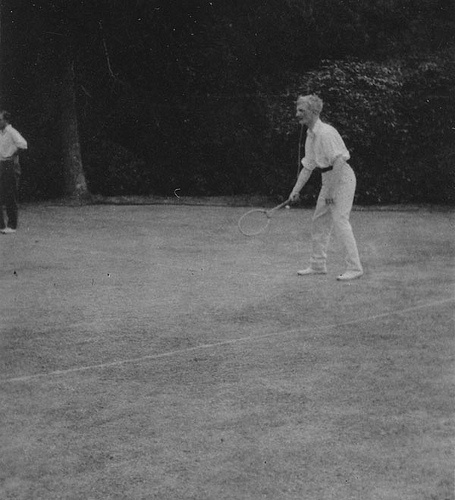Describe the objects in this image and their specific colors. I can see people in black, darkgray, gray, and lightgray tones, people in gray and black tones, and tennis racket in gray and black tones in this image. 